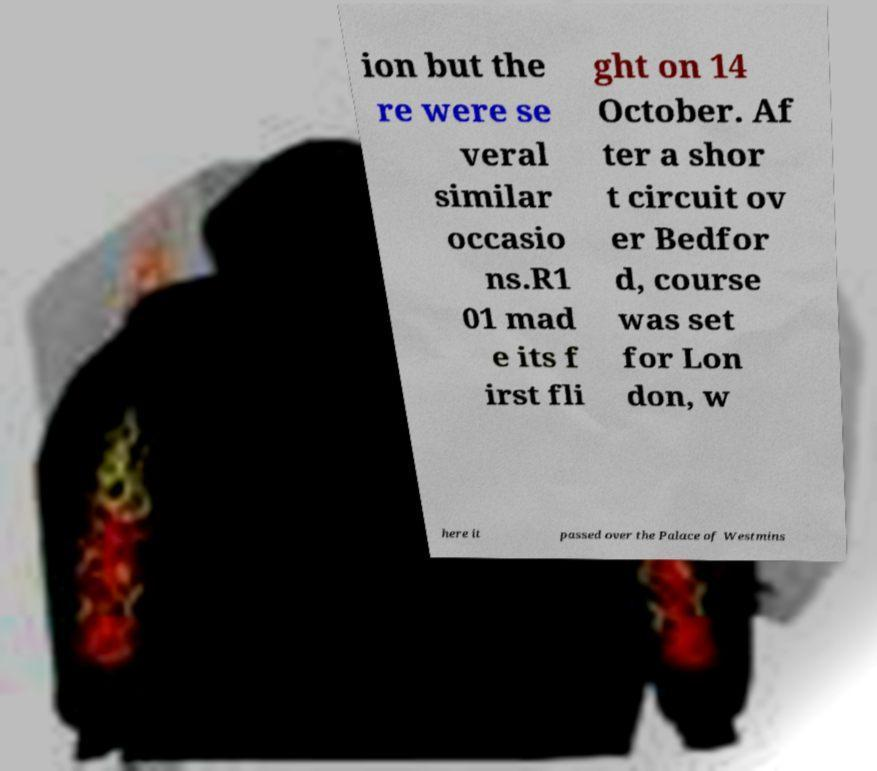I need the written content from this picture converted into text. Can you do that? ion but the re were se veral similar occasio ns.R1 01 mad e its f irst fli ght on 14 October. Af ter a shor t circuit ov er Bedfor d, course was set for Lon don, w here it passed over the Palace of Westmins 